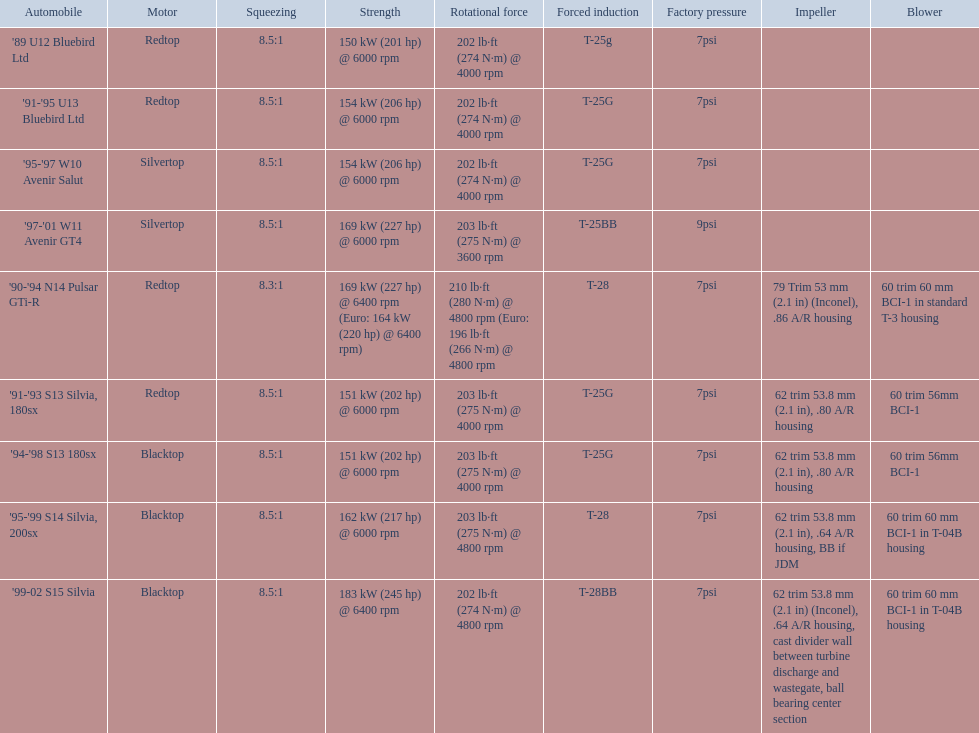What cars are there? '89 U12 Bluebird Ltd, 7psi, '91-'95 U13 Bluebird Ltd, 7psi, '95-'97 W10 Avenir Salut, 7psi, '97-'01 W11 Avenir GT4, 9psi, '90-'94 N14 Pulsar GTi-R, 7psi, '91-'93 S13 Silvia, 180sx, 7psi, '94-'98 S13 180sx, 7psi, '95-'99 S14 Silvia, 200sx, 7psi, '99-02 S15 Silvia, 7psi. Which stock boost is over 7psi? '97-'01 W11 Avenir GT4, 9psi. What car is it? '97-'01 W11 Avenir GT4. 